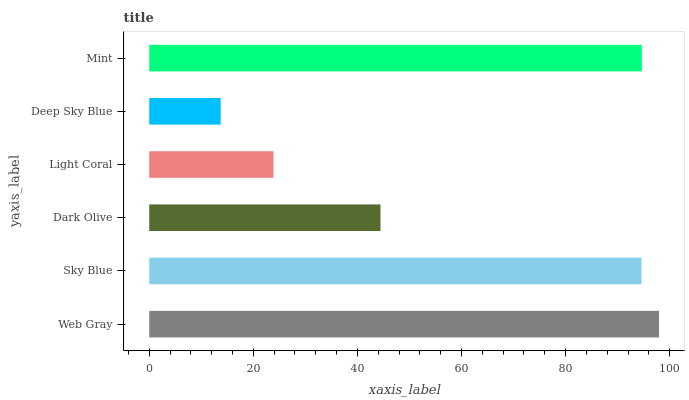Is Deep Sky Blue the minimum?
Answer yes or no. Yes. Is Web Gray the maximum?
Answer yes or no. Yes. Is Sky Blue the minimum?
Answer yes or no. No. Is Sky Blue the maximum?
Answer yes or no. No. Is Web Gray greater than Sky Blue?
Answer yes or no. Yes. Is Sky Blue less than Web Gray?
Answer yes or no. Yes. Is Sky Blue greater than Web Gray?
Answer yes or no. No. Is Web Gray less than Sky Blue?
Answer yes or no. No. Is Sky Blue the high median?
Answer yes or no. Yes. Is Dark Olive the low median?
Answer yes or no. Yes. Is Deep Sky Blue the high median?
Answer yes or no. No. Is Light Coral the low median?
Answer yes or no. No. 